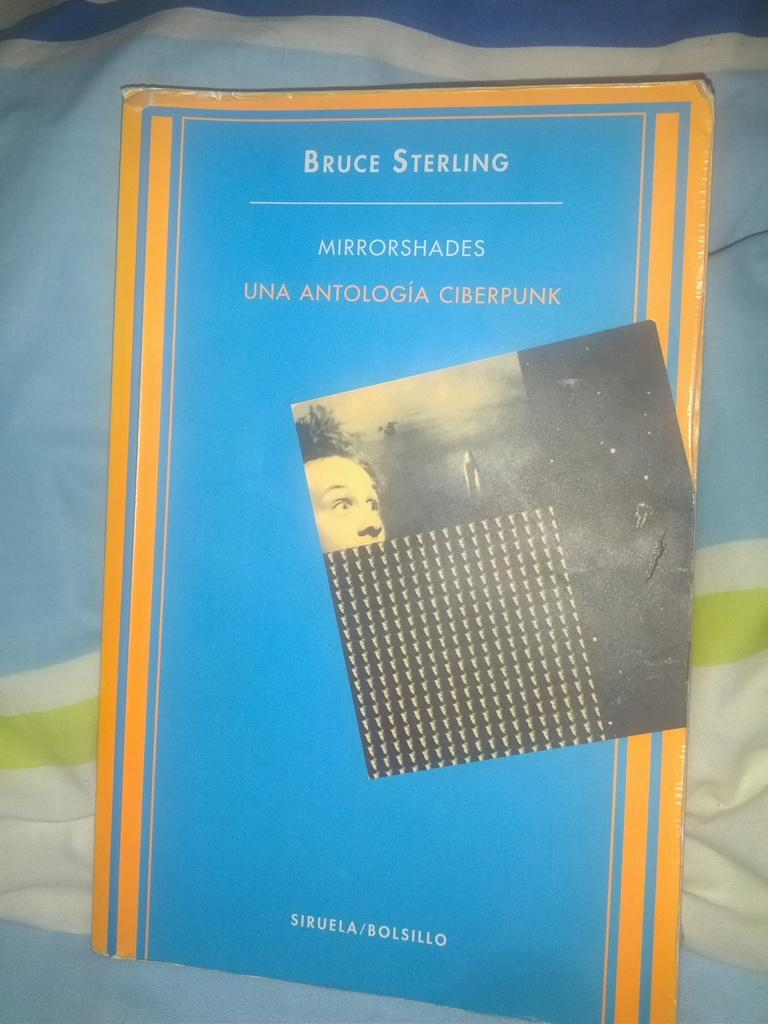Provide a one-sentence caption for the provided image. The cover of the book Mirrorshades in blue with yellow trim. 